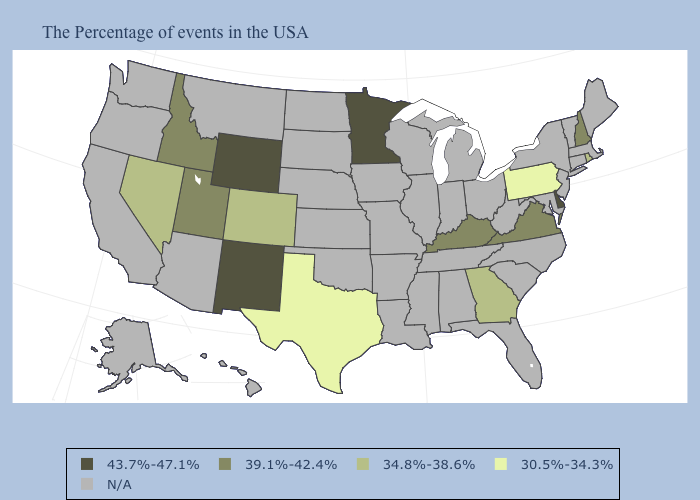What is the lowest value in states that border Texas?
Short answer required. 43.7%-47.1%. How many symbols are there in the legend?
Give a very brief answer. 5. Does Wyoming have the lowest value in the West?
Write a very short answer. No. Does the first symbol in the legend represent the smallest category?
Keep it brief. No. What is the lowest value in the MidWest?
Quick response, please. 43.7%-47.1%. Does Nevada have the lowest value in the West?
Concise answer only. Yes. How many symbols are there in the legend?
Quick response, please. 5. Does Minnesota have the highest value in the USA?
Keep it brief. Yes. Name the states that have a value in the range 39.1%-42.4%?
Be succinct. New Hampshire, Virginia, Kentucky, Utah, Idaho. Is the legend a continuous bar?
Give a very brief answer. No. Which states hav the highest value in the Northeast?
Short answer required. New Hampshire. What is the value of Kentucky?
Be succinct. 39.1%-42.4%. Which states hav the highest value in the MidWest?
Be succinct. Minnesota. What is the value of Arizona?
Short answer required. N/A. 